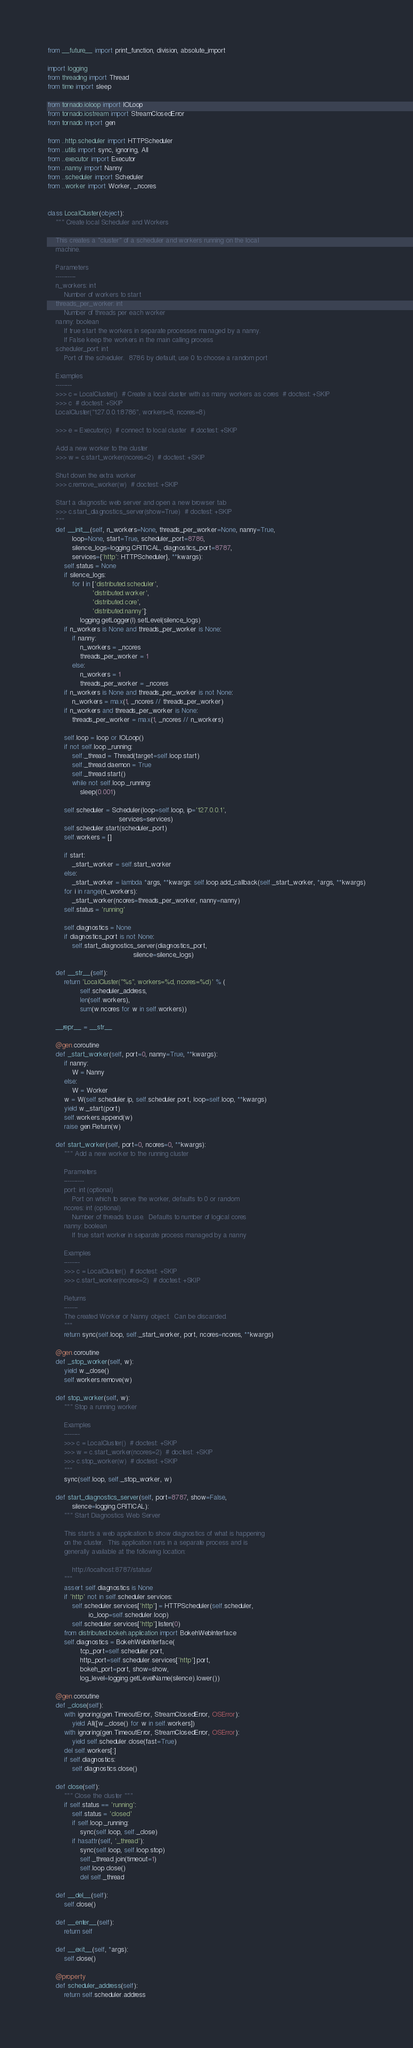Convert code to text. <code><loc_0><loc_0><loc_500><loc_500><_Python_>from __future__ import print_function, division, absolute_import

import logging
from threading import Thread
from time import sleep

from tornado.ioloop import IOLoop
from tornado.iostream import StreamClosedError
from tornado import gen

from ..http.scheduler import HTTPScheduler
from ..utils import sync, ignoring, All
from ..executor import Executor
from ..nanny import Nanny
from ..scheduler import Scheduler
from ..worker import Worker, _ncores


class LocalCluster(object):
    """ Create local Scheduler and Workers

    This creates a "cluster" of a scheduler and workers running on the local
    machine.

    Parameters
    ----------
    n_workers: int
        Number of workers to start
    threads_per_worker: int
        Number of threads per each worker
    nanny: boolean
        If true start the workers in separate processes managed by a nanny.
        If False keep the workers in the main calling process
    scheduler_port: int
        Port of the scheduler.  8786 by default, use 0 to choose a random port

    Examples
    --------
    >>> c = LocalCluster()  # Create a local cluster with as many workers as cores  # doctest: +SKIP
    >>> c  # doctest: +SKIP
    LocalCluster("127.0.0.1:8786", workers=8, ncores=8)

    >>> e = Executor(c)  # connect to local cluster  # doctest: +SKIP

    Add a new worker to the cluster
    >>> w = c.start_worker(ncores=2)  # doctest: +SKIP

    Shut down the extra worker
    >>> c.remove_worker(w)  # doctest: +SKIP

    Start a diagnostic web server and open a new browser tab
    >>> c.start_diagnostics_server(show=True)  # doctest: +SKIP
    """
    def __init__(self, n_workers=None, threads_per_worker=None, nanny=True,
            loop=None, start=True, scheduler_port=8786,
            silence_logs=logging.CRITICAL, diagnostics_port=8787,
            services={'http': HTTPScheduler}, **kwargs):
        self.status = None
        if silence_logs:
            for l in ['distributed.scheduler',
                      'distributed.worker',
                      'distributed.core',
                      'distributed.nanny']:
                logging.getLogger(l).setLevel(silence_logs)
        if n_workers is None and threads_per_worker is None:
            if nanny:
                n_workers = _ncores
                threads_per_worker = 1
            else:
                n_workers = 1
                threads_per_worker = _ncores
        if n_workers is None and threads_per_worker is not None:
            n_workers = max(1, _ncores // threads_per_worker)
        if n_workers and threads_per_worker is None:
            threads_per_worker = max(1, _ncores // n_workers)

        self.loop = loop or IOLoop()
        if not self.loop._running:
            self._thread = Thread(target=self.loop.start)
            self._thread.daemon = True
            self._thread.start()
            while not self.loop._running:
                sleep(0.001)

        self.scheduler = Scheduler(loop=self.loop, ip='127.0.0.1',
                                   services=services)
        self.scheduler.start(scheduler_port)
        self.workers = []

        if start:
            _start_worker = self.start_worker
        else:
            _start_worker = lambda *args, **kwargs: self.loop.add_callback(self._start_worker, *args, **kwargs)
        for i in range(n_workers):
            _start_worker(ncores=threads_per_worker, nanny=nanny)
        self.status = 'running'

        self.diagnostics = None
        if diagnostics_port is not None:
            self.start_diagnostics_server(diagnostics_port,
                                          silence=silence_logs)

    def __str__(self):
        return 'LocalCluster("%s", workers=%d, ncores=%d)' % (
                self.scheduler_address,
                len(self.workers),
                sum(w.ncores for w in self.workers))

    __repr__ = __str__

    @gen.coroutine
    def _start_worker(self, port=0, nanny=True, **kwargs):
        if nanny:
            W = Nanny
        else:
            W = Worker
        w = W(self.scheduler.ip, self.scheduler.port, loop=self.loop, **kwargs)
        yield w._start(port)
        self.workers.append(w)
        raise gen.Return(w)

    def start_worker(self, port=0, ncores=0, **kwargs):
        """ Add a new worker to the running cluster

        Parameters
        ----------
        port: int (optional)
            Port on which to serve the worker, defaults to 0 or random
        ncores: int (optional)
            Number of threads to use.  Defaults to number of logical cores
        nanny: boolean
            If true start worker in separate process managed by a nanny

        Examples
        --------
        >>> c = LocalCluster()  # doctest: +SKIP
        >>> c.start_worker(ncores=2)  # doctest: +SKIP

        Returns
        -------
        The created Worker or Nanny object.  Can be discarded.
        """
        return sync(self.loop, self._start_worker, port, ncores=ncores, **kwargs)

    @gen.coroutine
    def _stop_worker(self, w):
        yield w._close()
        self.workers.remove(w)

    def stop_worker(self, w):
        """ Stop a running worker

        Examples
        --------
        >>> c = LocalCluster()  # doctest: +SKIP
        >>> w = c.start_worker(ncores=2)  # doctest: +SKIP
        >>> c.stop_worker(w)  # doctest: +SKIP
        """
        sync(self.loop, self._stop_worker, w)

    def start_diagnostics_server(self, port=8787, show=False,
            silence=logging.CRITICAL):
        """ Start Diagnostics Web Server

        This starts a web application to show diagnostics of what is happening
        on the cluster.  This application runs in a separate process and is
        generally available at the following location:

            http://localhost:8787/status/
        """
        assert self.diagnostics is None
        if 'http' not in self.scheduler.services:
            self.scheduler.services['http'] = HTTPScheduler(self.scheduler,
                    io_loop=self.scheduler.loop)
            self.scheduler.services['http'].listen(0)
        from distributed.bokeh.application import BokehWebInterface
        self.diagnostics = BokehWebInterface(
                tcp_port=self.scheduler.port,
                http_port=self.scheduler.services['http'].port,
                bokeh_port=port, show=show,
                log_level=logging.getLevelName(silence).lower())

    @gen.coroutine
    def _close(self):
        with ignoring(gen.TimeoutError, StreamClosedError, OSError):
            yield All([w._close() for w in self.workers])
        with ignoring(gen.TimeoutError, StreamClosedError, OSError):
            yield self.scheduler.close(fast=True)
        del self.workers[:]
        if self.diagnostics:
            self.diagnostics.close()

    def close(self):
        """ Close the cluster """
        if self.status == 'running':
            self.status = 'closed'
            if self.loop._running:
                sync(self.loop, self._close)
            if hasattr(self, '_thread'):
                sync(self.loop, self.loop.stop)
                self._thread.join(timeout=1)
                self.loop.close()
                del self._thread

    def __del__(self):
        self.close()

    def __enter__(self):
        return self

    def __exit__(self, *args):
        self.close()

    @property
    def scheduler_address(self):
        return self.scheduler.address
</code> 